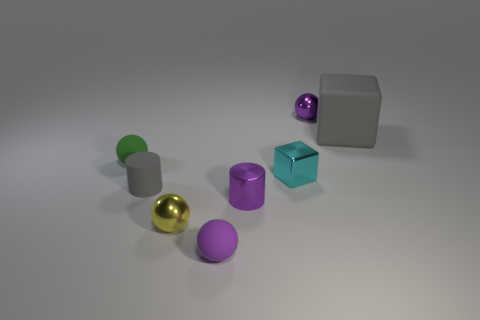There is a green object that is the same size as the gray cylinder; what is its material?
Offer a terse response. Rubber. There is a purple sphere that is left of the tiny sphere behind the green matte object; what is its material?
Your answer should be very brief. Rubber. Is the shape of the tiny rubber thing that is in front of the yellow object the same as  the small yellow object?
Your answer should be very brief. Yes. What is the color of the cylinder that is the same material as the cyan block?
Your answer should be compact. Purple. There is a object that is behind the large gray block; what is its material?
Offer a terse response. Metal. There is a large matte object; is its shape the same as the small purple shiny object that is in front of the large thing?
Provide a succinct answer. No. What is the object that is both behind the small block and in front of the big gray thing made of?
Offer a terse response. Rubber. There is a cube that is the same size as the purple metal cylinder; what is its color?
Your response must be concise. Cyan. Are the big gray object and the tiny purple object that is to the right of the cyan metallic thing made of the same material?
Your answer should be compact. No. What number of other things are the same size as the green ball?
Offer a very short reply. 6. 